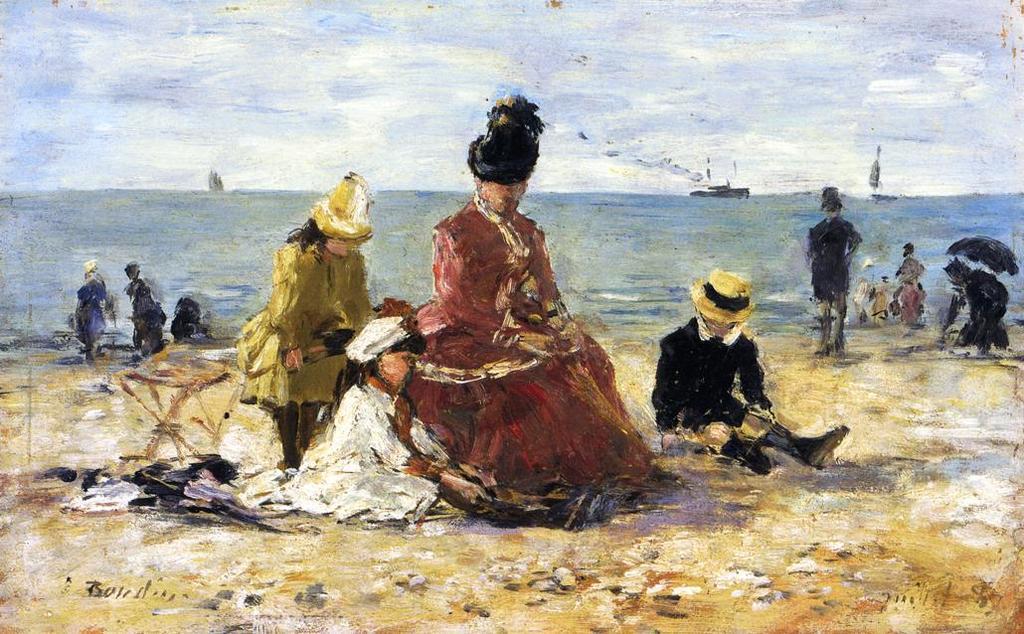In one or two sentences, can you explain what this image depicts? In this image I can see the painting in which I can see few persons, the ground, the water and few boats on the water. In the background I can see the sky. 